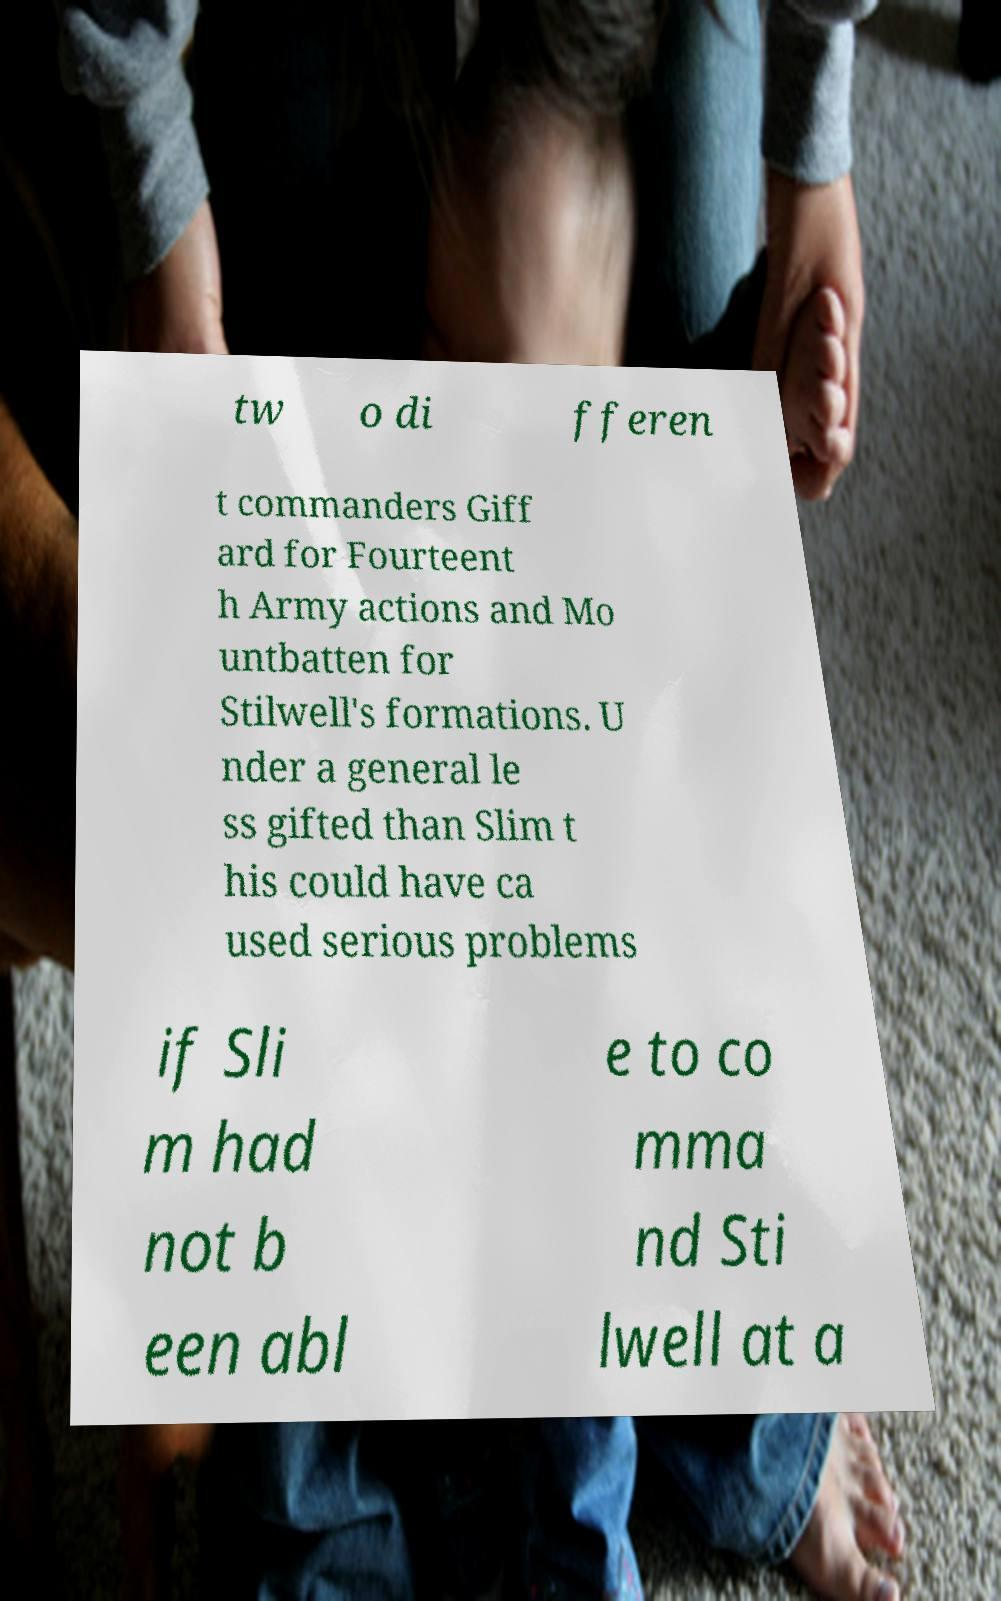I need the written content from this picture converted into text. Can you do that? tw o di fferen t commanders Giff ard for Fourteent h Army actions and Mo untbatten for Stilwell's formations. U nder a general le ss gifted than Slim t his could have ca used serious problems if Sli m had not b een abl e to co mma nd Sti lwell at a 